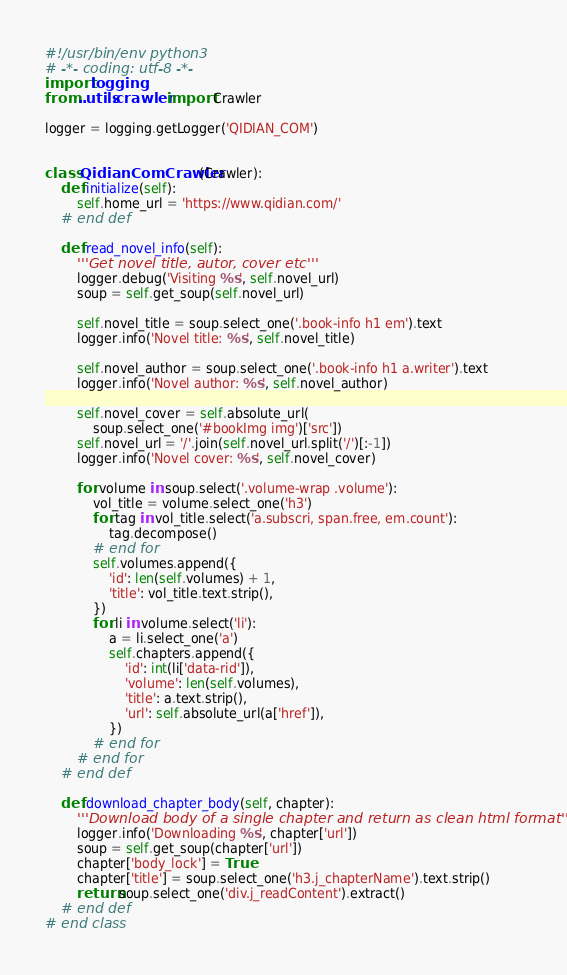Convert code to text. <code><loc_0><loc_0><loc_500><loc_500><_Python_>#!/usr/bin/env python3
# -*- coding: utf-8 -*-
import logging
from ..utils.crawler import Crawler

logger = logging.getLogger('QIDIAN_COM')


class QidianComCrawler(Crawler):
    def initialize(self):
        self.home_url = 'https://www.qidian.com/'
    # end def

    def read_novel_info(self):
        '''Get novel title, autor, cover etc'''
        logger.debug('Visiting %s', self.novel_url)
        soup = self.get_soup(self.novel_url)

        self.novel_title = soup.select_one('.book-info h1 em').text
        logger.info('Novel title: %s', self.novel_title)

        self.novel_author = soup.select_one('.book-info h1 a.writer').text
        logger.info('Novel author: %s', self.novel_author)

        self.novel_cover = self.absolute_url(
            soup.select_one('#bookImg img')['src'])
        self.novel_url = '/'.join(self.novel_url.split('/')[:-1])
        logger.info('Novel cover: %s', self.novel_cover)

        for volume in soup.select('.volume-wrap .volume'):
            vol_title = volume.select_one('h3')
            for tag in vol_title.select('a.subscri, span.free, em.count'):
                tag.decompose()
            # end for
            self.volumes.append({
                'id': len(self.volumes) + 1,
                'title': vol_title.text.strip(),
            })
            for li in volume.select('li'):
                a = li.select_one('a')
                self.chapters.append({
                    'id': int(li['data-rid']),
                    'volume': len(self.volumes),
                    'title': a.text.strip(),
                    'url': self.absolute_url(a['href']),
                })
            # end for
        # end for
    # end def

    def download_chapter_body(self, chapter):
        '''Download body of a single chapter and return as clean html format'''
        logger.info('Downloading %s', chapter['url'])
        soup = self.get_soup(chapter['url'])
        chapter['body_lock'] = True
        chapter['title'] = soup.select_one('h3.j_chapterName').text.strip()
        return soup.select_one('div.j_readContent').extract()
    # end def
# end class
</code> 